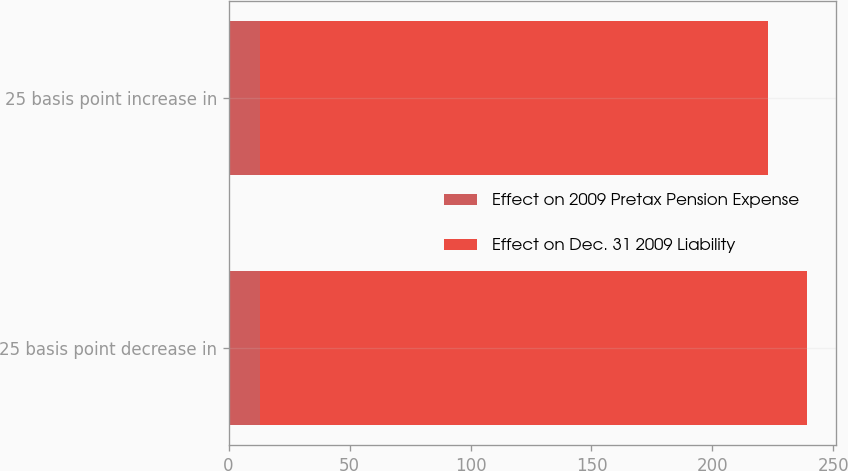Convert chart to OTSL. <chart><loc_0><loc_0><loc_500><loc_500><stacked_bar_chart><ecel><fcel>25 basis point decrease in<fcel>25 basis point increase in<nl><fcel>Effect on 2009 Pretax Pension Expense<fcel>13<fcel>13<nl><fcel>Effect on Dec. 31 2009 Liability<fcel>226<fcel>210<nl></chart> 